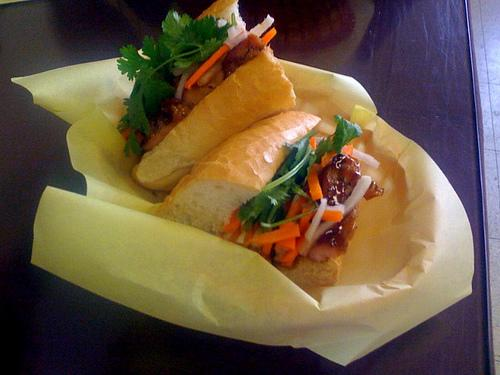How many individual sandwich pieces are in the image? two 